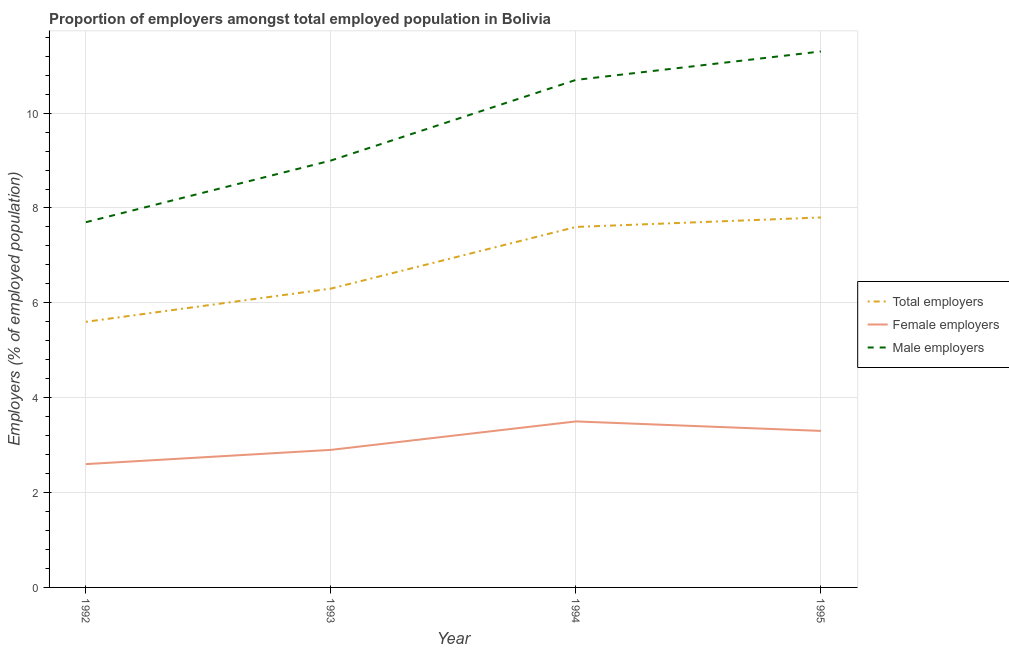Does the line corresponding to percentage of female employers intersect with the line corresponding to percentage of total employers?
Ensure brevity in your answer.  No. What is the percentage of female employers in 1992?
Give a very brief answer. 2.6. Across all years, what is the maximum percentage of male employers?
Your response must be concise. 11.3. Across all years, what is the minimum percentage of female employers?
Your response must be concise. 2.6. In which year was the percentage of male employers maximum?
Make the answer very short. 1995. What is the total percentage of female employers in the graph?
Ensure brevity in your answer.  12.3. What is the difference between the percentage of total employers in 1994 and that in 1995?
Your answer should be compact. -0.2. What is the difference between the percentage of male employers in 1994 and the percentage of female employers in 1992?
Your response must be concise. 8.1. What is the average percentage of total employers per year?
Provide a short and direct response. 6.83. In the year 1993, what is the difference between the percentage of total employers and percentage of female employers?
Offer a very short reply. 3.4. In how many years, is the percentage of male employers greater than 2 %?
Give a very brief answer. 4. What is the ratio of the percentage of male employers in 1992 to that in 1995?
Provide a short and direct response. 0.68. Is the percentage of total employers in 1994 less than that in 1995?
Give a very brief answer. Yes. What is the difference between the highest and the second highest percentage of total employers?
Ensure brevity in your answer.  0.2. What is the difference between the highest and the lowest percentage of female employers?
Keep it short and to the point. 0.9. Is it the case that in every year, the sum of the percentage of total employers and percentage of female employers is greater than the percentage of male employers?
Your response must be concise. No. Is the percentage of total employers strictly greater than the percentage of male employers over the years?
Your answer should be compact. No. Is the percentage of total employers strictly less than the percentage of female employers over the years?
Your answer should be very brief. No. How many lines are there?
Offer a terse response. 3. How many years are there in the graph?
Offer a terse response. 4. What is the difference between two consecutive major ticks on the Y-axis?
Ensure brevity in your answer.  2. Are the values on the major ticks of Y-axis written in scientific E-notation?
Offer a terse response. No. Does the graph contain grids?
Keep it short and to the point. Yes. What is the title of the graph?
Provide a succinct answer. Proportion of employers amongst total employed population in Bolivia. Does "Ireland" appear as one of the legend labels in the graph?
Your response must be concise. No. What is the label or title of the Y-axis?
Provide a short and direct response. Employers (% of employed population). What is the Employers (% of employed population) of Total employers in 1992?
Make the answer very short. 5.6. What is the Employers (% of employed population) of Female employers in 1992?
Keep it short and to the point. 2.6. What is the Employers (% of employed population) in Male employers in 1992?
Your answer should be very brief. 7.7. What is the Employers (% of employed population) in Total employers in 1993?
Ensure brevity in your answer.  6.3. What is the Employers (% of employed population) of Female employers in 1993?
Provide a short and direct response. 2.9. What is the Employers (% of employed population) of Total employers in 1994?
Make the answer very short. 7.6. What is the Employers (% of employed population) of Female employers in 1994?
Your response must be concise. 3.5. What is the Employers (% of employed population) of Male employers in 1994?
Ensure brevity in your answer.  10.7. What is the Employers (% of employed population) in Total employers in 1995?
Make the answer very short. 7.8. What is the Employers (% of employed population) of Female employers in 1995?
Ensure brevity in your answer.  3.3. What is the Employers (% of employed population) of Male employers in 1995?
Your answer should be very brief. 11.3. Across all years, what is the maximum Employers (% of employed population) of Total employers?
Offer a terse response. 7.8. Across all years, what is the maximum Employers (% of employed population) of Female employers?
Your response must be concise. 3.5. Across all years, what is the maximum Employers (% of employed population) in Male employers?
Ensure brevity in your answer.  11.3. Across all years, what is the minimum Employers (% of employed population) of Total employers?
Keep it short and to the point. 5.6. Across all years, what is the minimum Employers (% of employed population) in Female employers?
Provide a short and direct response. 2.6. Across all years, what is the minimum Employers (% of employed population) of Male employers?
Your response must be concise. 7.7. What is the total Employers (% of employed population) of Total employers in the graph?
Your answer should be compact. 27.3. What is the total Employers (% of employed population) of Female employers in the graph?
Ensure brevity in your answer.  12.3. What is the total Employers (% of employed population) in Male employers in the graph?
Your answer should be compact. 38.7. What is the difference between the Employers (% of employed population) of Male employers in 1992 and that in 1993?
Your answer should be compact. -1.3. What is the difference between the Employers (% of employed population) in Total employers in 1992 and that in 1994?
Offer a terse response. -2. What is the difference between the Employers (% of employed population) in Male employers in 1992 and that in 1994?
Offer a terse response. -3. What is the difference between the Employers (% of employed population) of Total employers in 1992 and that in 1995?
Your response must be concise. -2.2. What is the difference between the Employers (% of employed population) of Female employers in 1992 and that in 1995?
Give a very brief answer. -0.7. What is the difference between the Employers (% of employed population) of Total employers in 1993 and that in 1995?
Keep it short and to the point. -1.5. What is the difference between the Employers (% of employed population) of Male employers in 1994 and that in 1995?
Ensure brevity in your answer.  -0.6. What is the difference between the Employers (% of employed population) of Total employers in 1992 and the Employers (% of employed population) of Female employers in 1995?
Your answer should be very brief. 2.3. What is the difference between the Employers (% of employed population) of Female employers in 1992 and the Employers (% of employed population) of Male employers in 1995?
Your response must be concise. -8.7. What is the difference between the Employers (% of employed population) of Total employers in 1993 and the Employers (% of employed population) of Male employers in 1994?
Offer a very short reply. -4.4. What is the difference between the Employers (% of employed population) of Total employers in 1993 and the Employers (% of employed population) of Female employers in 1995?
Your answer should be very brief. 3. What is the difference between the Employers (% of employed population) in Female employers in 1993 and the Employers (% of employed population) in Male employers in 1995?
Ensure brevity in your answer.  -8.4. What is the difference between the Employers (% of employed population) of Total employers in 1994 and the Employers (% of employed population) of Female employers in 1995?
Your response must be concise. 4.3. What is the difference between the Employers (% of employed population) of Female employers in 1994 and the Employers (% of employed population) of Male employers in 1995?
Your response must be concise. -7.8. What is the average Employers (% of employed population) of Total employers per year?
Your answer should be very brief. 6.83. What is the average Employers (% of employed population) of Female employers per year?
Provide a short and direct response. 3.08. What is the average Employers (% of employed population) in Male employers per year?
Give a very brief answer. 9.68. In the year 1992, what is the difference between the Employers (% of employed population) of Total employers and Employers (% of employed population) of Male employers?
Keep it short and to the point. -2.1. In the year 1993, what is the difference between the Employers (% of employed population) of Total employers and Employers (% of employed population) of Female employers?
Offer a terse response. 3.4. In the year 1993, what is the difference between the Employers (% of employed population) in Total employers and Employers (% of employed population) in Male employers?
Offer a very short reply. -2.7. In the year 1993, what is the difference between the Employers (% of employed population) in Female employers and Employers (% of employed population) in Male employers?
Ensure brevity in your answer.  -6.1. In the year 1994, what is the difference between the Employers (% of employed population) of Total employers and Employers (% of employed population) of Female employers?
Provide a succinct answer. 4.1. In the year 1995, what is the difference between the Employers (% of employed population) in Total employers and Employers (% of employed population) in Female employers?
Offer a very short reply. 4.5. What is the ratio of the Employers (% of employed population) of Female employers in 1992 to that in 1993?
Provide a succinct answer. 0.9. What is the ratio of the Employers (% of employed population) in Male employers in 1992 to that in 1993?
Provide a short and direct response. 0.86. What is the ratio of the Employers (% of employed population) of Total employers in 1992 to that in 1994?
Ensure brevity in your answer.  0.74. What is the ratio of the Employers (% of employed population) in Female employers in 1992 to that in 1994?
Make the answer very short. 0.74. What is the ratio of the Employers (% of employed population) of Male employers in 1992 to that in 1994?
Offer a terse response. 0.72. What is the ratio of the Employers (% of employed population) of Total employers in 1992 to that in 1995?
Ensure brevity in your answer.  0.72. What is the ratio of the Employers (% of employed population) of Female employers in 1992 to that in 1995?
Your response must be concise. 0.79. What is the ratio of the Employers (% of employed population) of Male employers in 1992 to that in 1995?
Your answer should be very brief. 0.68. What is the ratio of the Employers (% of employed population) in Total employers in 1993 to that in 1994?
Offer a very short reply. 0.83. What is the ratio of the Employers (% of employed population) in Female employers in 1993 to that in 1994?
Provide a succinct answer. 0.83. What is the ratio of the Employers (% of employed population) in Male employers in 1993 to that in 1994?
Provide a succinct answer. 0.84. What is the ratio of the Employers (% of employed population) in Total employers in 1993 to that in 1995?
Give a very brief answer. 0.81. What is the ratio of the Employers (% of employed population) of Female employers in 1993 to that in 1995?
Ensure brevity in your answer.  0.88. What is the ratio of the Employers (% of employed population) of Male employers in 1993 to that in 1995?
Your answer should be very brief. 0.8. What is the ratio of the Employers (% of employed population) in Total employers in 1994 to that in 1995?
Offer a very short reply. 0.97. What is the ratio of the Employers (% of employed population) of Female employers in 1994 to that in 1995?
Your response must be concise. 1.06. What is the ratio of the Employers (% of employed population) in Male employers in 1994 to that in 1995?
Provide a short and direct response. 0.95. What is the difference between the highest and the second highest Employers (% of employed population) in Male employers?
Provide a succinct answer. 0.6. What is the difference between the highest and the lowest Employers (% of employed population) in Total employers?
Offer a terse response. 2.2. 